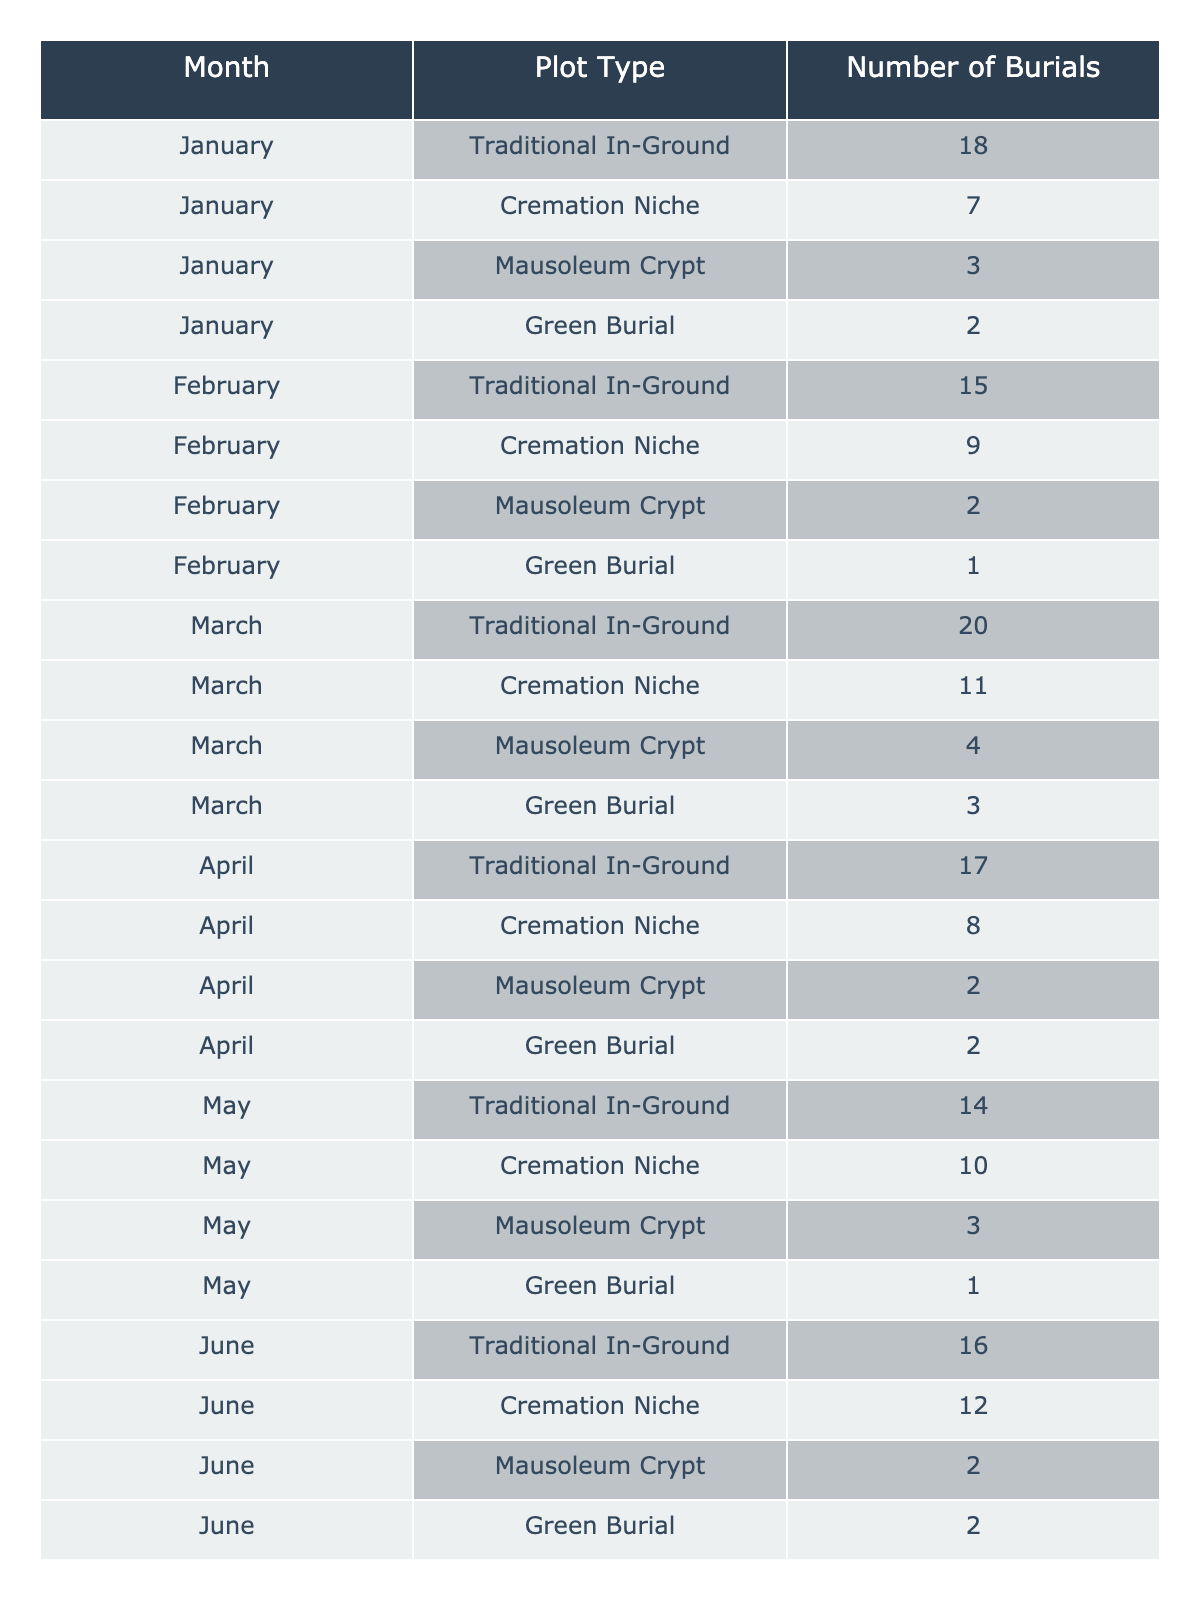What was the total number of burials in August? Adding the number of burials for each plot type in August: Traditional In-Ground (21) + Cremation Niche (15) + Mausoleum Crypt (4) + Green Burial (2) = 42
Answer: 42 Which plot type saw the most burials in December? In December, the plot types had the following burials: Traditional In-Ground (23), Cremation Niche (16), Mausoleum Crypt (4), Green Burial (2). The highest number is from Traditional In-Ground.
Answer: Traditional In-Ground How many more Traditional In-Ground burials were there in October compared to February? October had 22 Traditional In-Ground burials and February had 15. The difference is 22 - 15 = 7.
Answer: 7 What is the average number of burials per month for Green Burials? Summing the Green Burials over the months gives 2 + 1 + 3 + 2 + 1 + 2 + 1 + 2 = 15. There are 12 months, thus the average is 15/12 = 1.25.
Answer: 1.25 Did the number of Cremation Niche burials increase more significantly in the first half of the year compared to the second half? The total for the first half (January to June) is 7 + 9 + 11 + 8 + 10 + 12 = 57, and for the second half (July to December) it is 13 + 15 + 11 + 14 + 12 + 16 = 81. Since 81 > 57, the burials did increase more in the second half.
Answer: Yes Which month had the highest number of burials across all plot types? The total burials for each month are: January (30), February (27), March (38), April (29), May (28), June (42), July (36), August (42), September (35), October (45), November (36), December (45). The highest totals were in October and December, both having 45.
Answer: October and December How many burials were there in Traditional In-Ground across the entire year? Summing all Traditional In-Ground burials: 18 + 15 + 20 + 17 + 14 + 16 + 19 + 21 + 18 + 22 + 20 + 23 =  227.
Answer: 227 What percentage of total burials in September were from Cremation Niches? Total burials in September amounted to 35, with Cremation Niches accounting for 11 burials. Thus, the percentage is (11/35) * 100 ≈ 31.43%.
Answer: ~31.43% Which plot type had the least number of burials in November? In November the number of burials were: Traditional In-Ground (20), Cremation Niche (12), Mausoleum Crypt (3), Green Burial (1). The least is the Green Burial with 1 burial.
Answer: Green Burial Is there a month where the number of Mausoleum Crypt burials was at least 5? By reviewing the Mausoleum Crypt burials by month: January (3), February (2), March (4), April (2), May (3), June (2), July (3), August (4), September (3), October (5), November (3), December (4), the only month with at least 5 was October.
Answer: Yes 